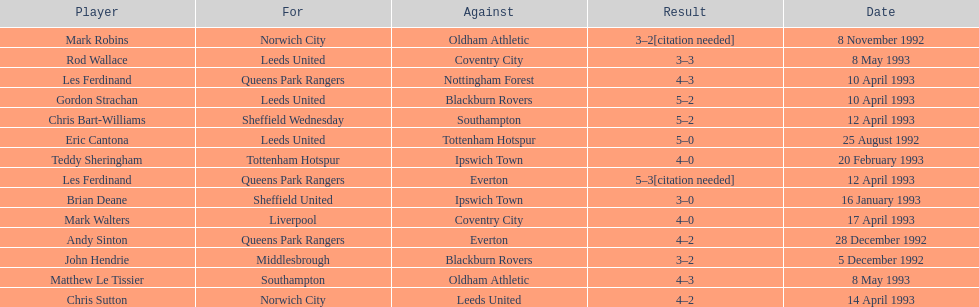How many players were for leeds united? 3. 